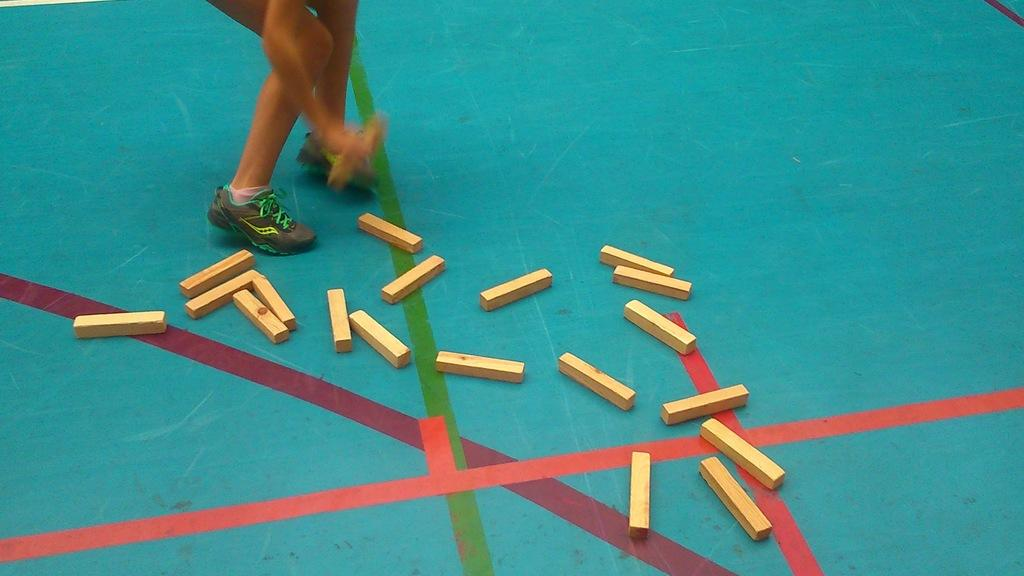Who or what can be seen in the image? There is a person in the image. What parts of the person's body are visible? The person's legs and hands are visible. What type of footwear is the person wearing? The person is wearing shoes. What objects are on the floor in the image? There are wooden blocks on the floor in the image. What type of rhythm does the person feel ashamed of in the image? There is no indication of rhythm or shame in the image; it only shows a person with visible legs, hands, and shoes, along with wooden blocks on the floor. 